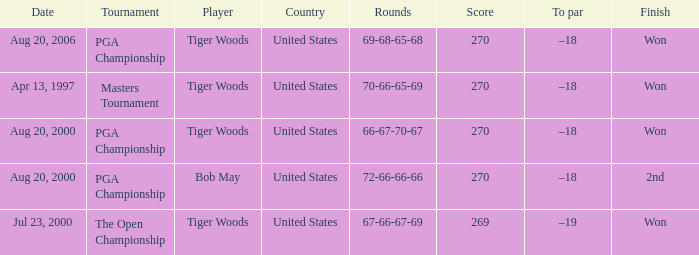What country hosts the tournament the open championship? United States. 